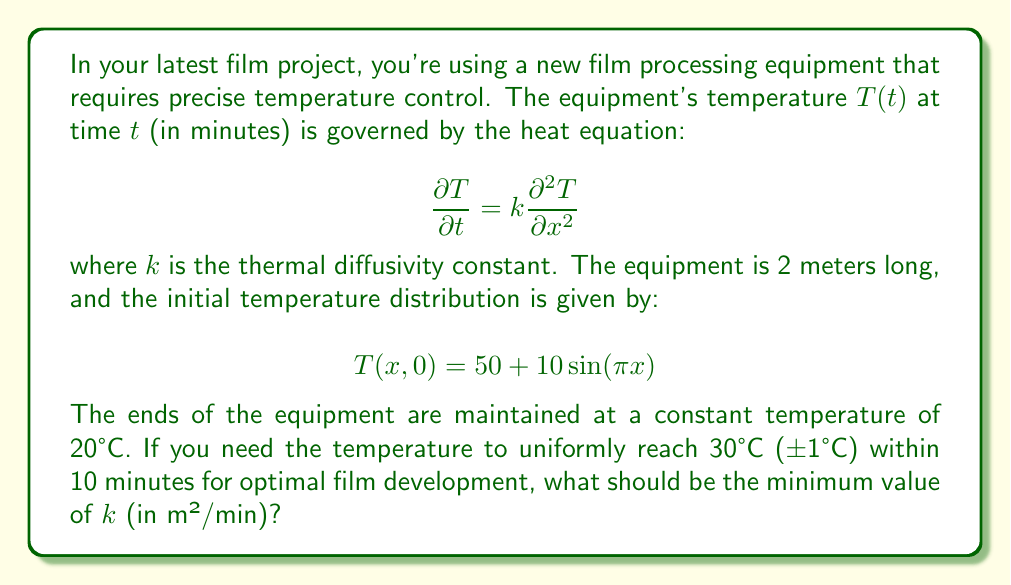Solve this math problem. To solve this problem, we'll use the separation of variables method for the heat equation:

1) The general solution for the heat equation with the given boundary conditions is:

   $$T(x,t) = 20 + \sum_{n=1}^{\infty} B_n \sin(\frac{n\pi x}{L})e^{-k(\frac{n\pi}{L})^2t}$$

   where $L = 2$ (length of the equipment).

2) From the initial condition, we can see that only the first term ($n=1$) is present:

   $$T(x,0) = 50 + 10\sin(\pi x) = 20 + 30\sin(\frac{\pi x}{2})$$

   So, $B_1 = 30$ and all other $B_n = 0$.

3) Our solution simplifies to:

   $$T(x,t) = 20 + 30\sin(\frac{\pi x}{2})e^{-k(\frac{\pi}{2})^2t}$$

4) For uniform temperature within ±1°C after 10 minutes, the exponential term should be very small:

   $$30e^{-k(\frac{\pi}{2})^2 \cdot 10} \leq 1$$

5) Solving this inequality:

   $$e^{-k(\frac{\pi}{2})^2 \cdot 10} \leq \frac{1}{30}$$
   $$-k(\frac{\pi}{2})^2 \cdot 10 \leq \ln(\frac{1}{30})$$
   $$k \geq \frac{-\ln(\frac{1}{30})}{10(\frac{\pi}{2})^2} \approx 0.0871$$

Therefore, the minimum value of $k$ should be approximately 0.0871 m²/min.
Answer: $k \approx 0.0871$ m²/min 